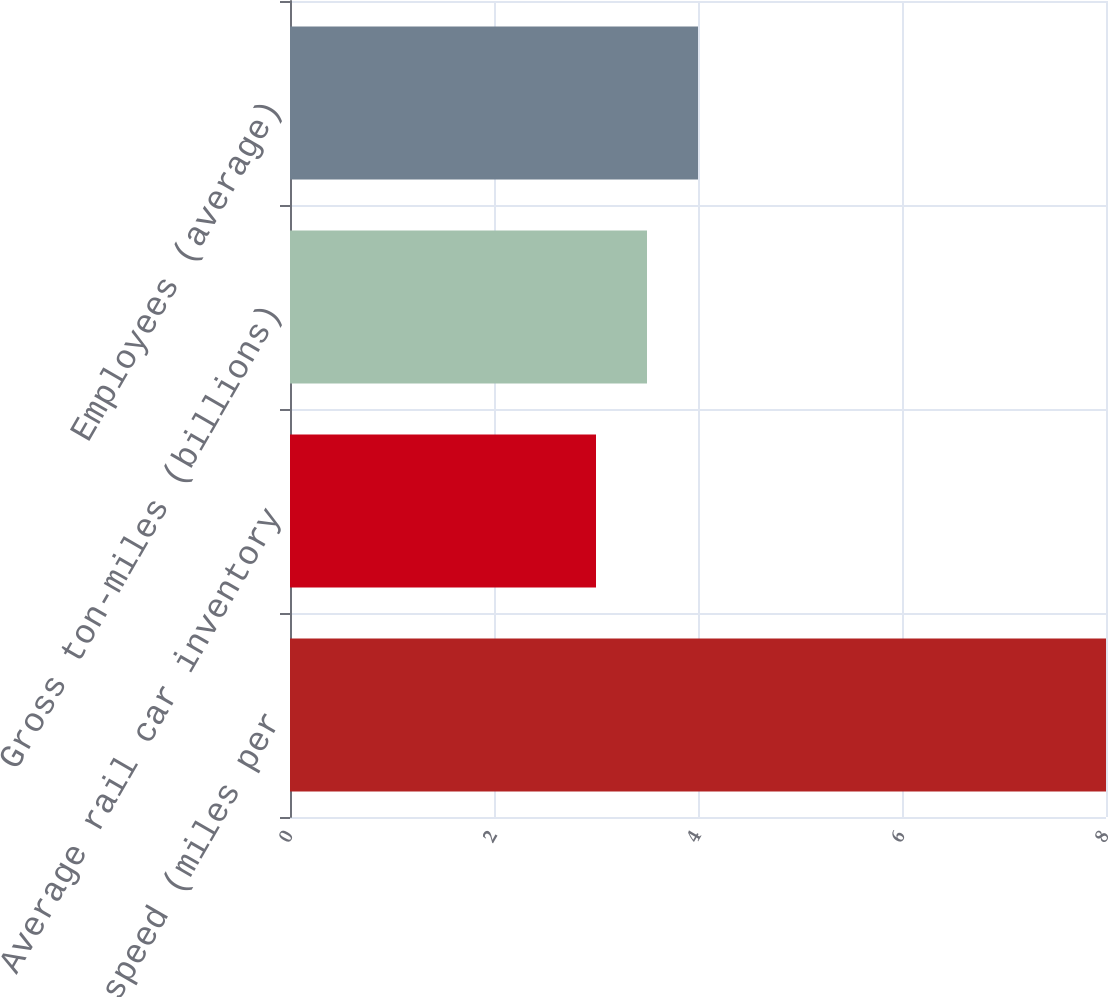Convert chart to OTSL. <chart><loc_0><loc_0><loc_500><loc_500><bar_chart><fcel>Average train speed (miles per<fcel>Average rail car inventory<fcel>Gross ton-miles (billions)<fcel>Employees (average)<nl><fcel>8<fcel>3<fcel>3.5<fcel>4<nl></chart> 